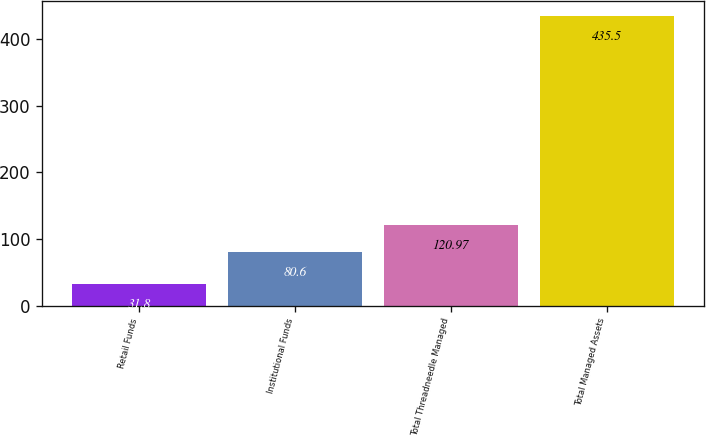Convert chart to OTSL. <chart><loc_0><loc_0><loc_500><loc_500><bar_chart><fcel>Retail Funds<fcel>Institutional Funds<fcel>Total Threadneedle Managed<fcel>Total Managed Assets<nl><fcel>31.8<fcel>80.6<fcel>120.97<fcel>435.5<nl></chart> 